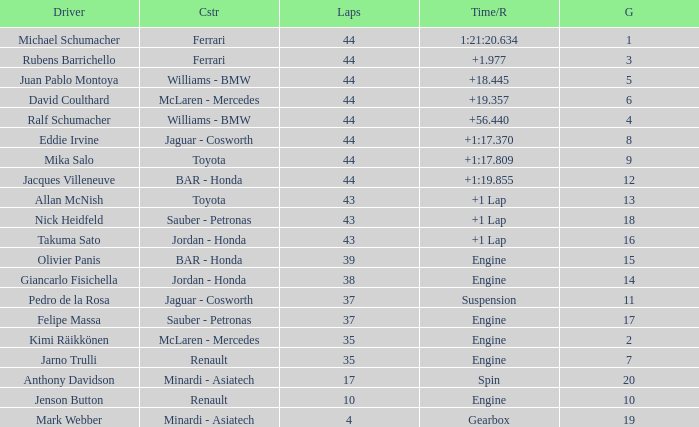What was the retired time on someone who had 43 laps on a grip of 18? +1 Lap. Give me the full table as a dictionary. {'header': ['Driver', 'Cstr', 'Laps', 'Time/R', 'G'], 'rows': [['Michael Schumacher', 'Ferrari', '44', '1:21:20.634', '1'], ['Rubens Barrichello', 'Ferrari', '44', '+1.977', '3'], ['Juan Pablo Montoya', 'Williams - BMW', '44', '+18.445', '5'], ['David Coulthard', 'McLaren - Mercedes', '44', '+19.357', '6'], ['Ralf Schumacher', 'Williams - BMW', '44', '+56.440', '4'], ['Eddie Irvine', 'Jaguar - Cosworth', '44', '+1:17.370', '8'], ['Mika Salo', 'Toyota', '44', '+1:17.809', '9'], ['Jacques Villeneuve', 'BAR - Honda', '44', '+1:19.855', '12'], ['Allan McNish', 'Toyota', '43', '+1 Lap', '13'], ['Nick Heidfeld', 'Sauber - Petronas', '43', '+1 Lap', '18'], ['Takuma Sato', 'Jordan - Honda', '43', '+1 Lap', '16'], ['Olivier Panis', 'BAR - Honda', '39', 'Engine', '15'], ['Giancarlo Fisichella', 'Jordan - Honda', '38', 'Engine', '14'], ['Pedro de la Rosa', 'Jaguar - Cosworth', '37', 'Suspension', '11'], ['Felipe Massa', 'Sauber - Petronas', '37', 'Engine', '17'], ['Kimi Räikkönen', 'McLaren - Mercedes', '35', 'Engine', '2'], ['Jarno Trulli', 'Renault', '35', 'Engine', '7'], ['Anthony Davidson', 'Minardi - Asiatech', '17', 'Spin', '20'], ['Jenson Button', 'Renault', '10', 'Engine', '10'], ['Mark Webber', 'Minardi - Asiatech', '4', 'Gearbox', '19']]} 